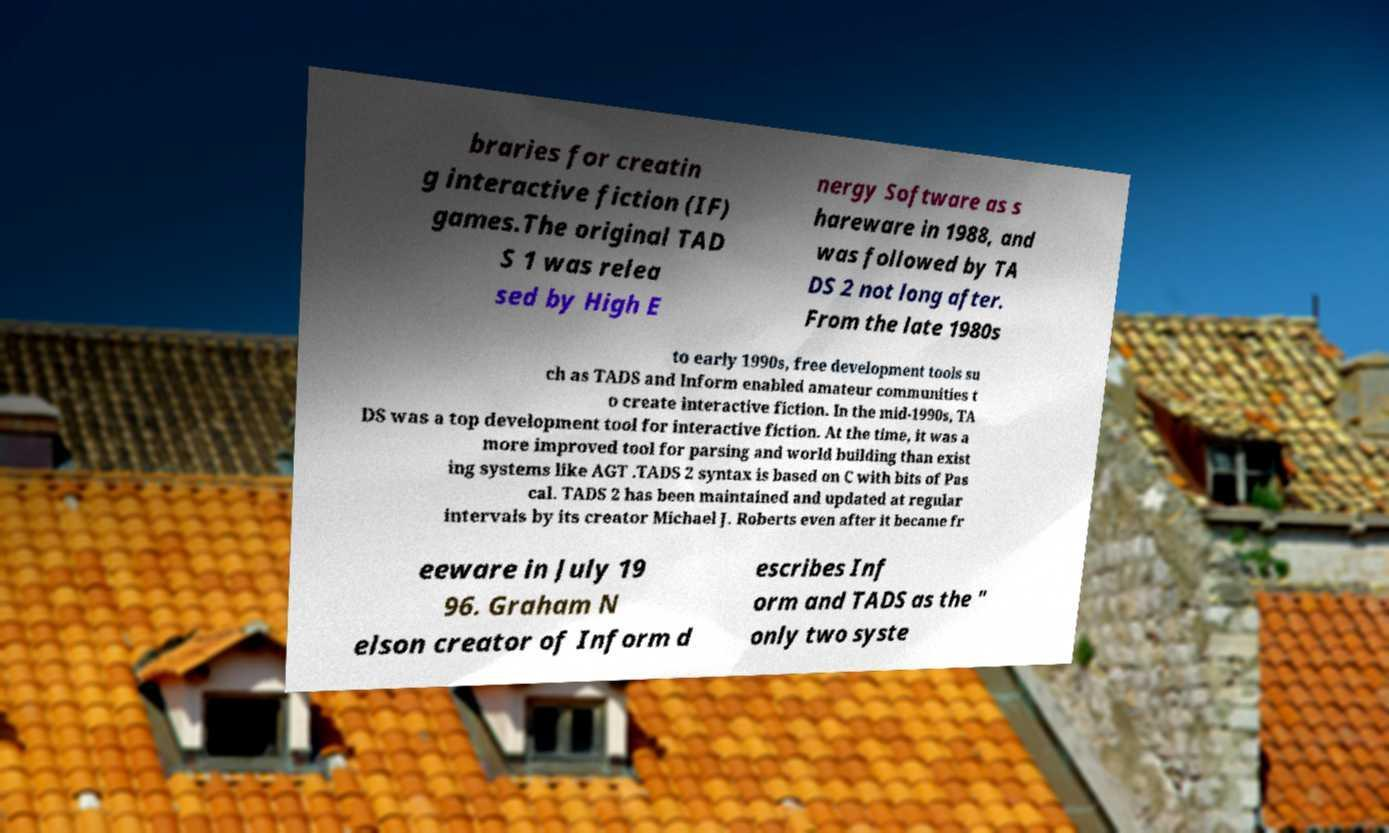I need the written content from this picture converted into text. Can you do that? braries for creatin g interactive fiction (IF) games.The original TAD S 1 was relea sed by High E nergy Software as s hareware in 1988, and was followed by TA DS 2 not long after. From the late 1980s to early 1990s, free development tools su ch as TADS and Inform enabled amateur communities t o create interactive fiction. In the mid-1990s, TA DS was a top development tool for interactive fiction. At the time, it was a more improved tool for parsing and world building than exist ing systems like AGT .TADS 2 syntax is based on C with bits of Pas cal. TADS 2 has been maintained and updated at regular intervals by its creator Michael J. Roberts even after it became fr eeware in July 19 96. Graham N elson creator of Inform d escribes Inf orm and TADS as the " only two syste 